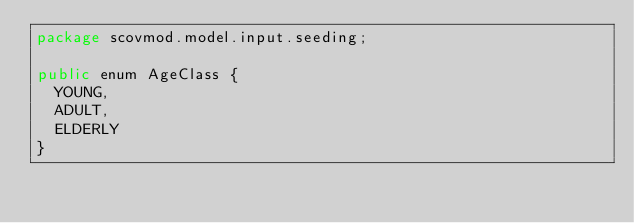<code> <loc_0><loc_0><loc_500><loc_500><_Java_>package scovmod.model.input.seeding;

public enum AgeClass {
	YOUNG,
	ADULT,
	ELDERLY
}
</code> 